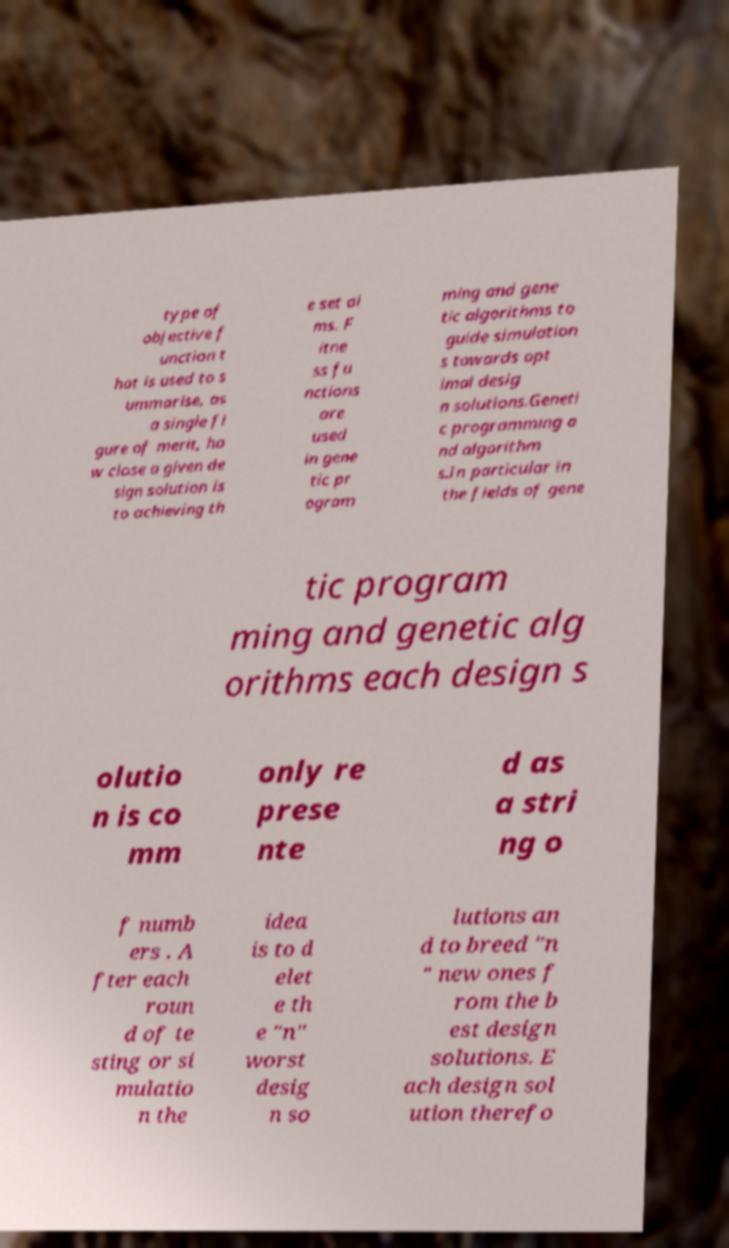Can you accurately transcribe the text from the provided image for me? type of objective f unction t hat is used to s ummarise, as a single fi gure of merit, ho w close a given de sign solution is to achieving th e set ai ms. F itne ss fu nctions are used in gene tic pr ogram ming and gene tic algorithms to guide simulation s towards opt imal desig n solutions.Geneti c programming a nd algorithm s.In particular in the fields of gene tic program ming and genetic alg orithms each design s olutio n is co mm only re prese nte d as a stri ng o f numb ers . A fter each roun d of te sting or si mulatio n the idea is to d elet e th e "n" worst desig n so lutions an d to breed "n " new ones f rom the b est design solutions. E ach design sol ution therefo 